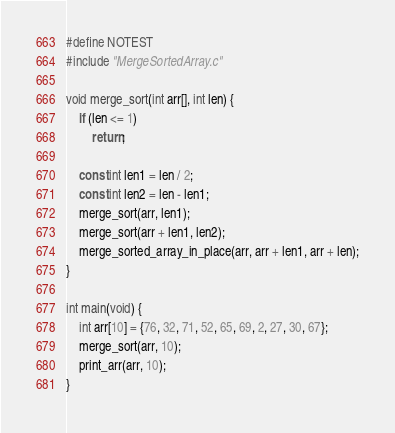Convert code to text. <code><loc_0><loc_0><loc_500><loc_500><_C_>#define NOTEST
#include "MergeSortedArray.c"

void merge_sort(int arr[], int len) {
    if (len <= 1)
        return;

    const int len1 = len / 2;
    const int len2 = len - len1;
    merge_sort(arr, len1);
    merge_sort(arr + len1, len2);
    merge_sorted_array_in_place(arr, arr + len1, arr + len);
}

int main(void) {
    int arr[10] = {76, 32, 71, 52, 65, 69, 2, 27, 30, 67};
    merge_sort(arr, 10);
    print_arr(arr, 10);
}
</code> 